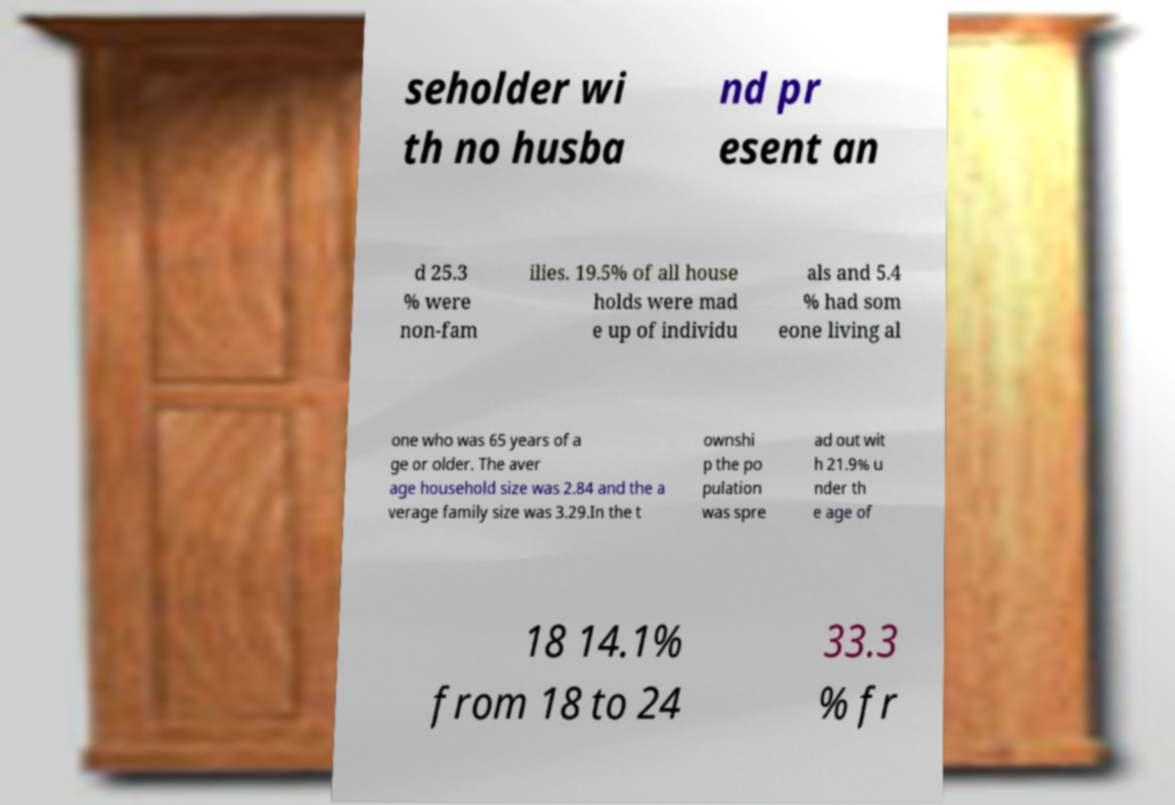I need the written content from this picture converted into text. Can you do that? seholder wi th no husba nd pr esent an d 25.3 % were non-fam ilies. 19.5% of all house holds were mad e up of individu als and 5.4 % had som eone living al one who was 65 years of a ge or older. The aver age household size was 2.84 and the a verage family size was 3.29.In the t ownshi p the po pulation was spre ad out wit h 21.9% u nder th e age of 18 14.1% from 18 to 24 33.3 % fr 